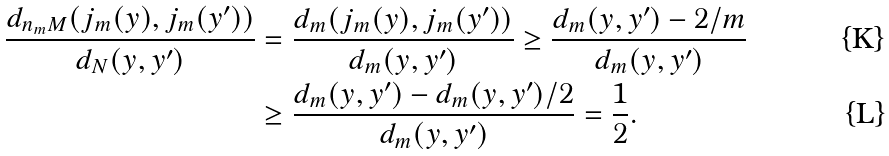Convert formula to latex. <formula><loc_0><loc_0><loc_500><loc_500>\frac { d _ { n _ { m } M } ( j _ { m } ( y ) , j _ { m } ( y ^ { \prime } ) ) } { d _ { N } ( y , y ^ { \prime } ) } & = \frac { d _ { m } ( j _ { m } ( y ) , j _ { m } ( y ^ { \prime } ) ) } { d _ { m } ( y , y ^ { \prime } ) } \geq \frac { d _ { m } ( y , y ^ { \prime } ) - 2 / m } { d _ { m } ( y , y ^ { \prime } ) } \\ & \geq \frac { d _ { m } ( y , y ^ { \prime } ) - d _ { m } ( y , y ^ { \prime } ) / 2 } { d _ { m } ( y , y ^ { \prime } ) } = \frac { 1 } { 2 } .</formula> 